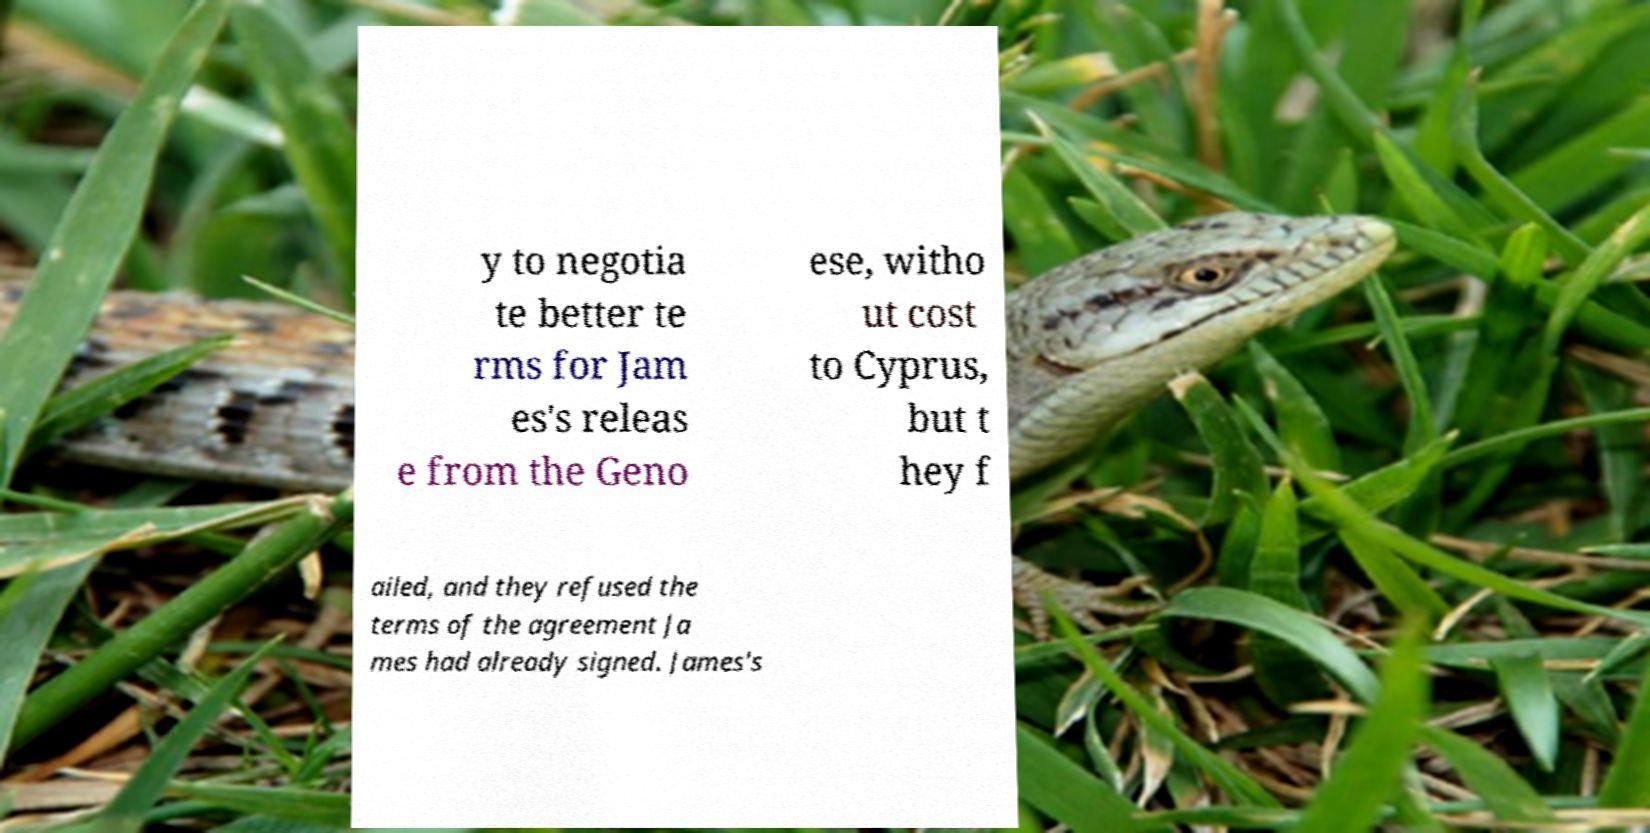What messages or text are displayed in this image? I need them in a readable, typed format. y to negotia te better te rms for Jam es's releas e from the Geno ese, witho ut cost to Cyprus, but t hey f ailed, and they refused the terms of the agreement Ja mes had already signed. James's 